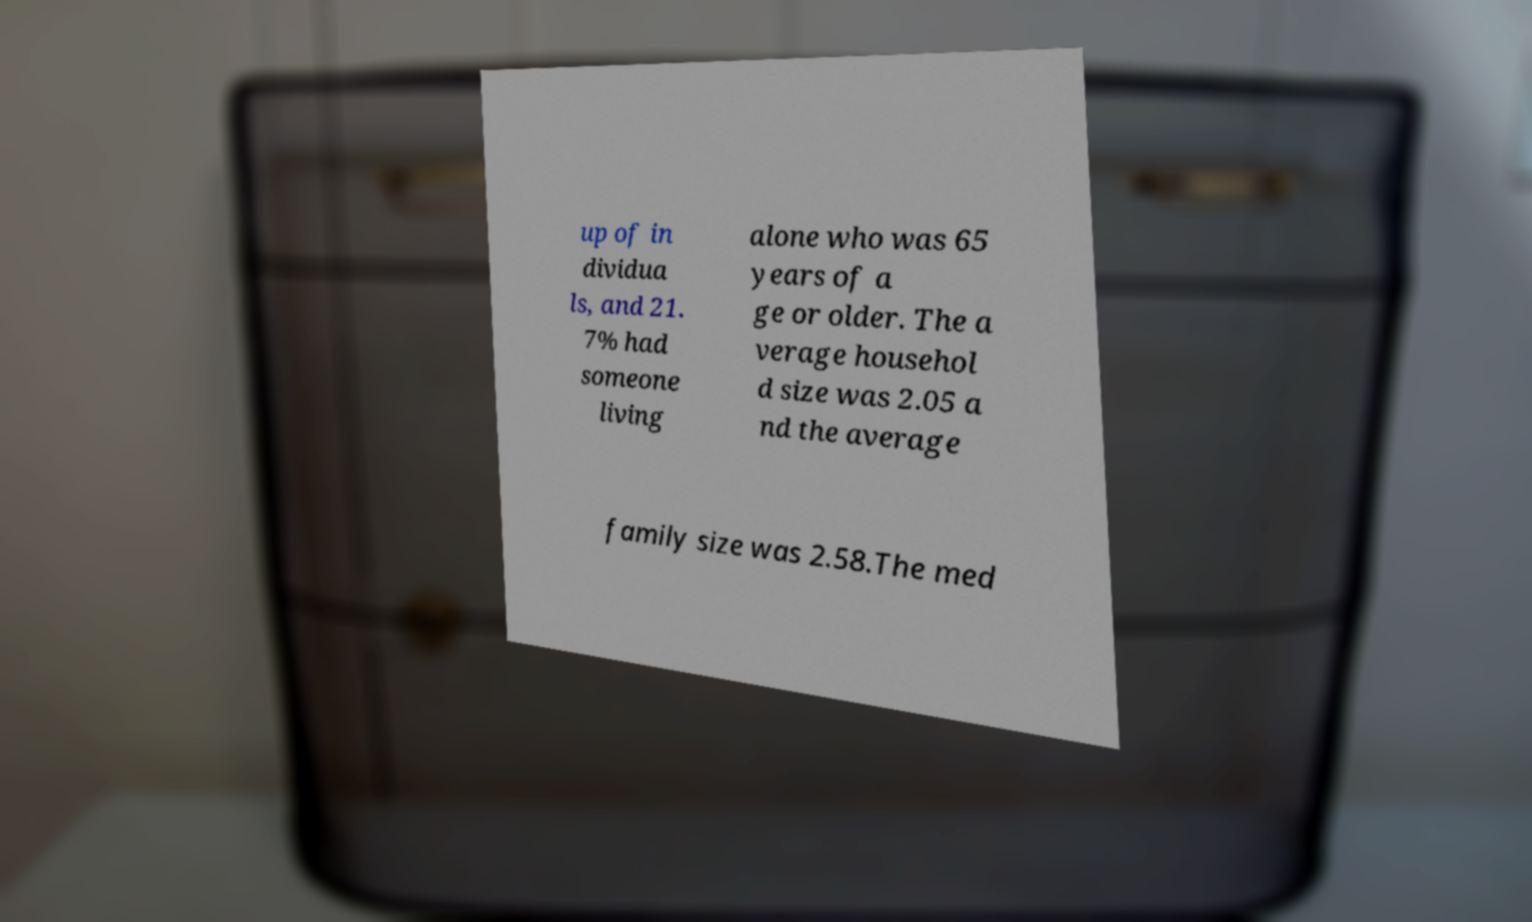Could you extract and type out the text from this image? up of in dividua ls, and 21. 7% had someone living alone who was 65 years of a ge or older. The a verage househol d size was 2.05 a nd the average family size was 2.58.The med 